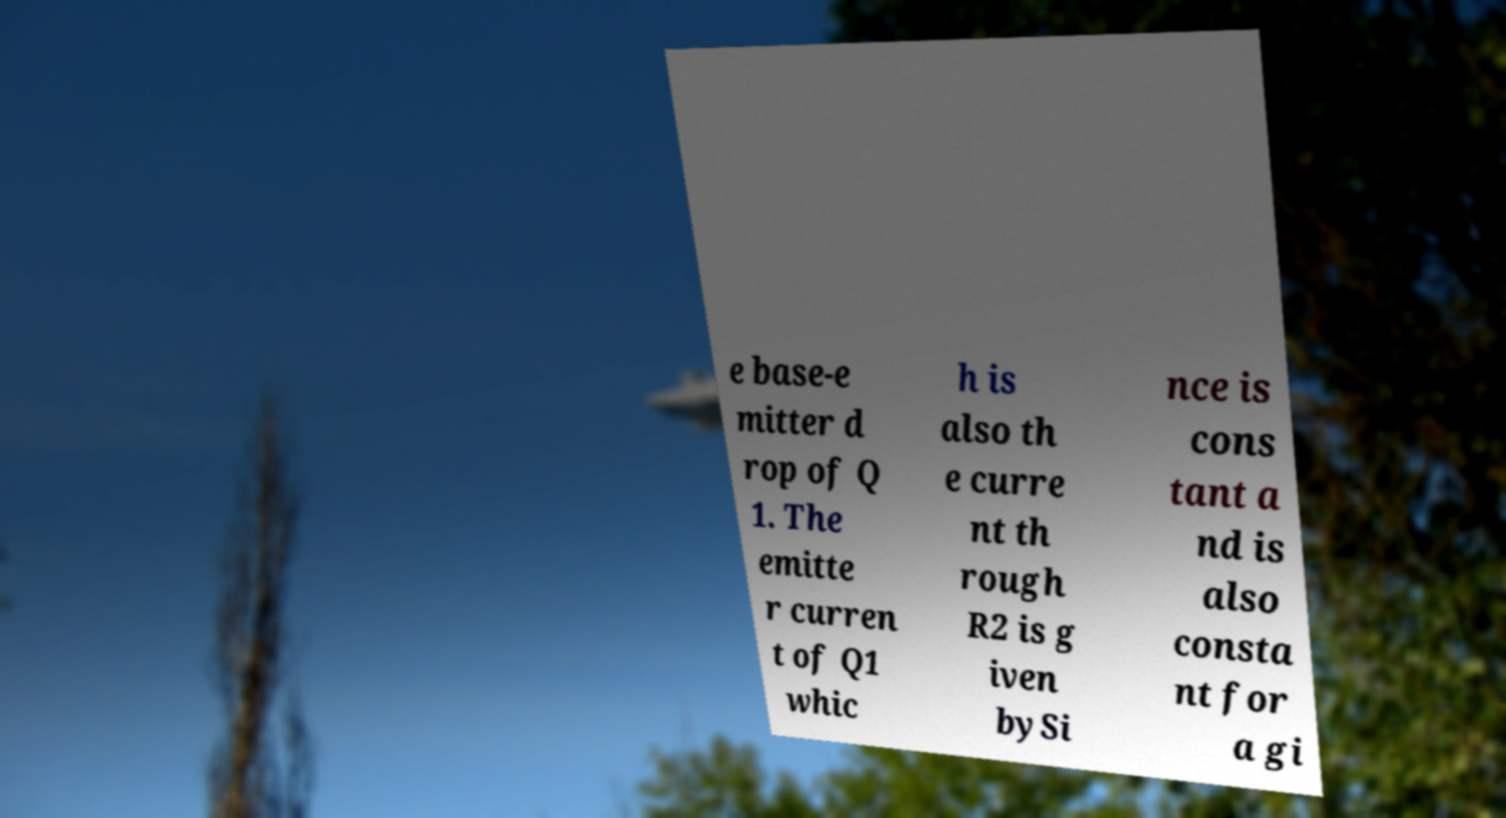Please read and relay the text visible in this image. What does it say? e base-e mitter d rop of Q 1. The emitte r curren t of Q1 whic h is also th e curre nt th rough R2 is g iven bySi nce is cons tant a nd is also consta nt for a gi 